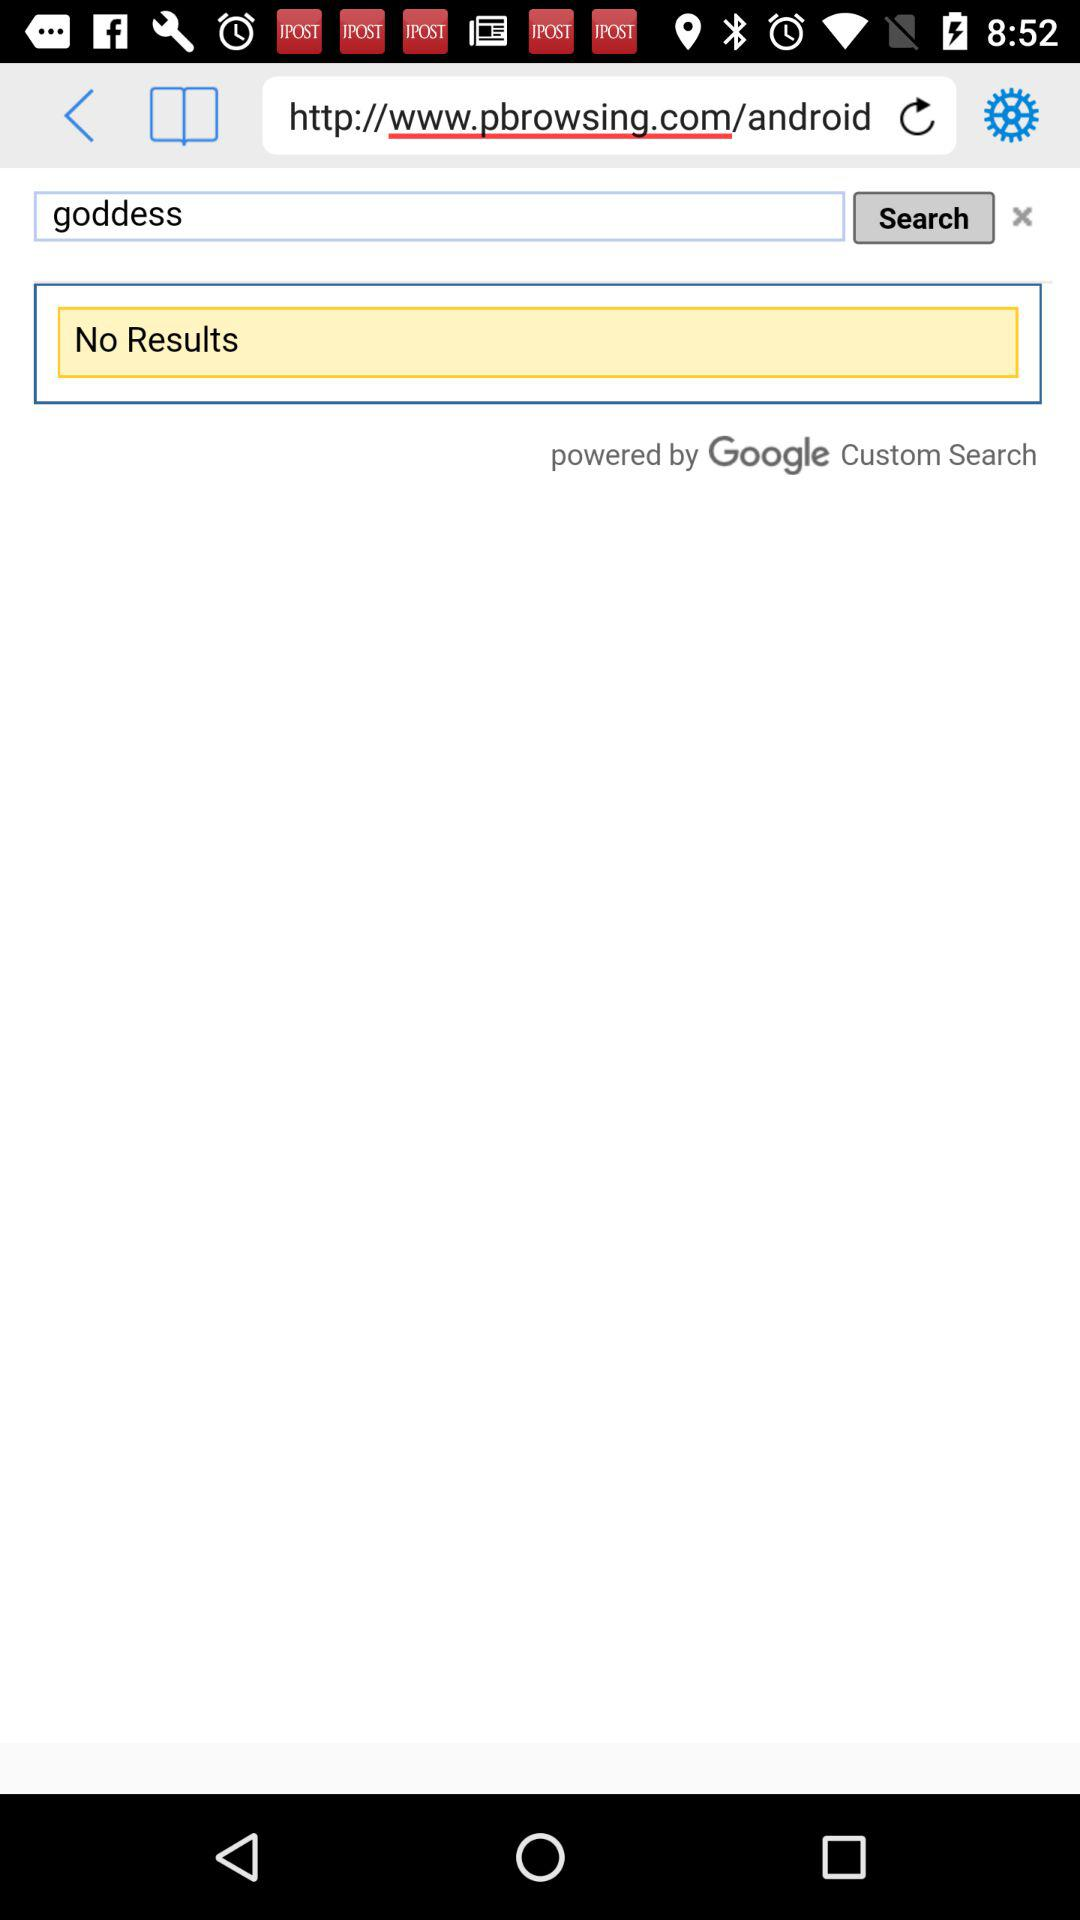How many text inputs have text?
Answer the question using a single word or phrase. 2 